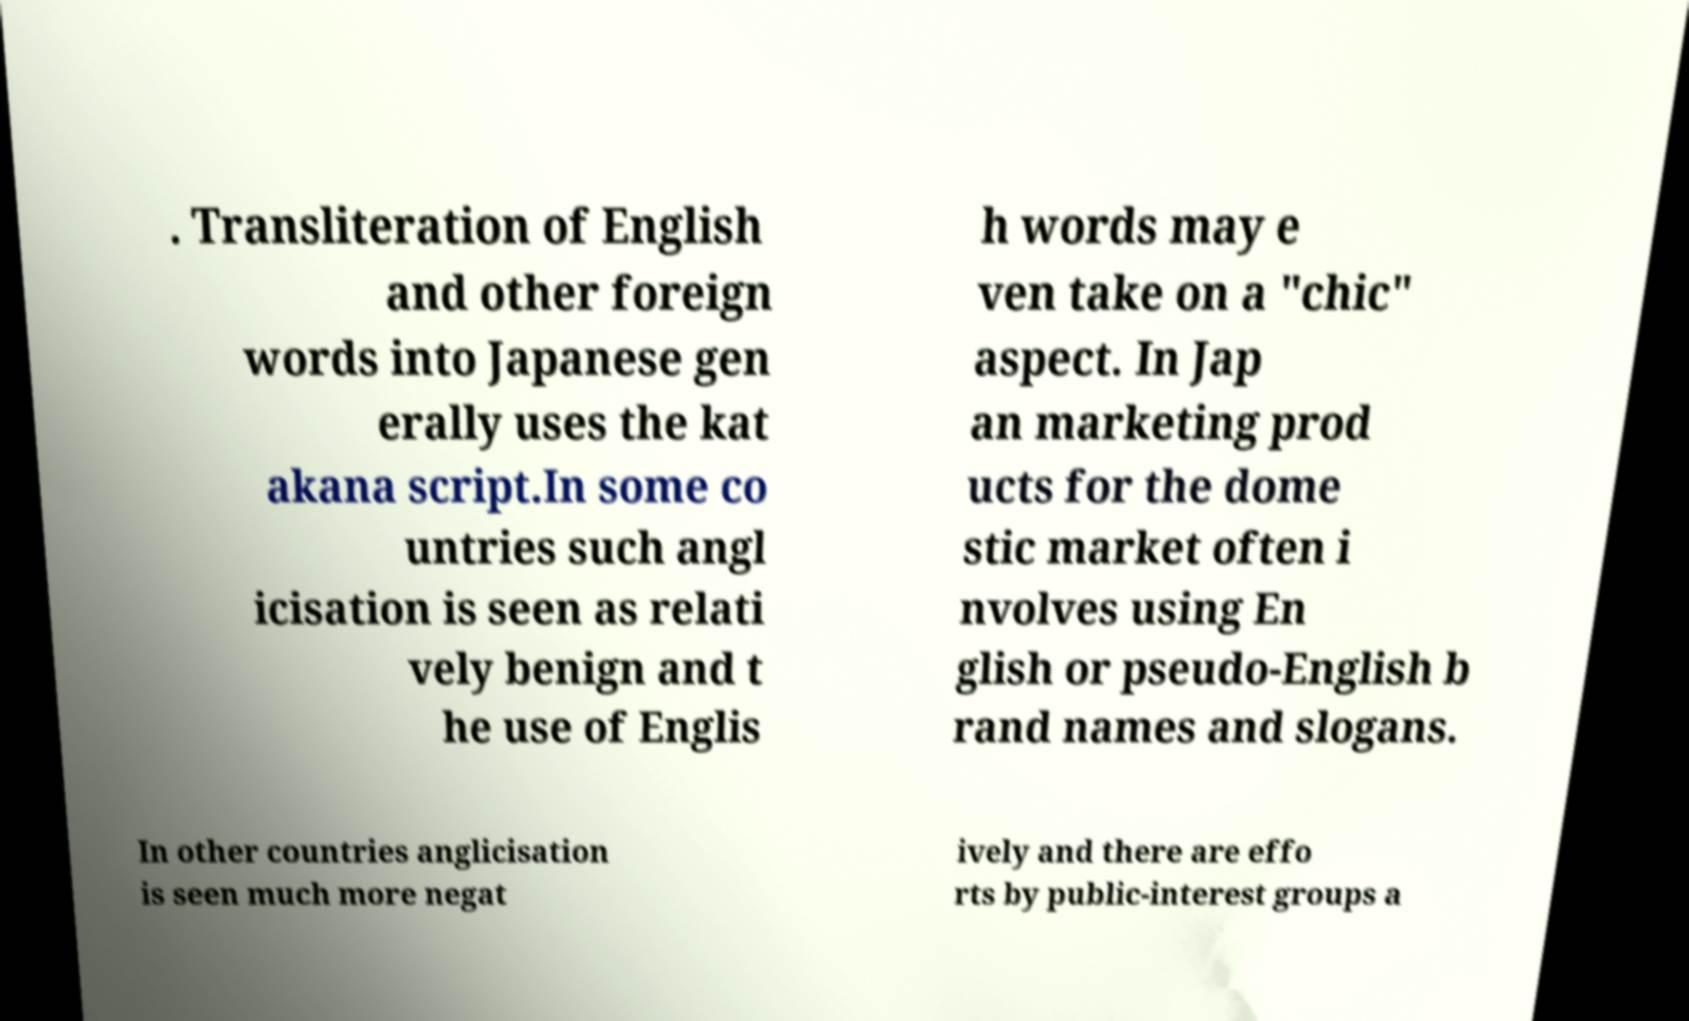Please identify and transcribe the text found in this image. . Transliteration of English and other foreign words into Japanese gen erally uses the kat akana script.In some co untries such angl icisation is seen as relati vely benign and t he use of Englis h words may e ven take on a "chic" aspect. In Jap an marketing prod ucts for the dome stic market often i nvolves using En glish or pseudo-English b rand names and slogans. In other countries anglicisation is seen much more negat ively and there are effo rts by public-interest groups a 